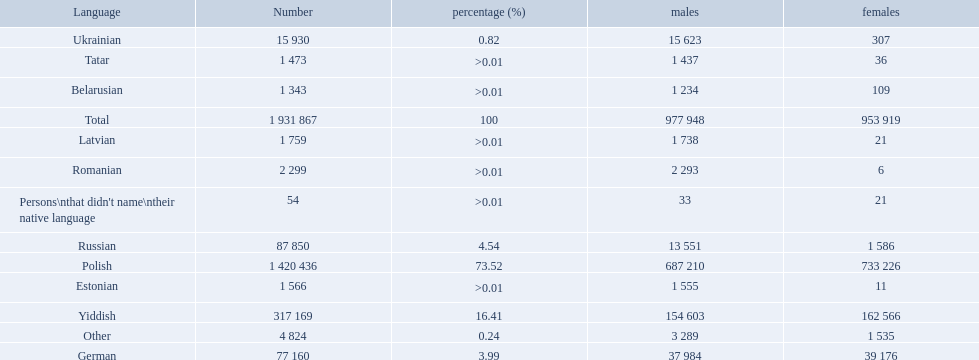What are all of the languages Polish, Yiddish, Russian, German, Ukrainian, Romanian, Latvian, Estonian, Tatar, Belarusian, Other, Persons\nthat didn't name\ntheir native language. What was the percentage of each? 73.52, 16.41, 4.54, 3.99, 0.82, >0.01, >0.01, >0.01, >0.01, >0.01, 0.24, >0.01. Which languages had a >0.01	 percentage? Romanian, Latvian, Estonian, Tatar, Belarusian. And of those, which is listed first? Romanian. 